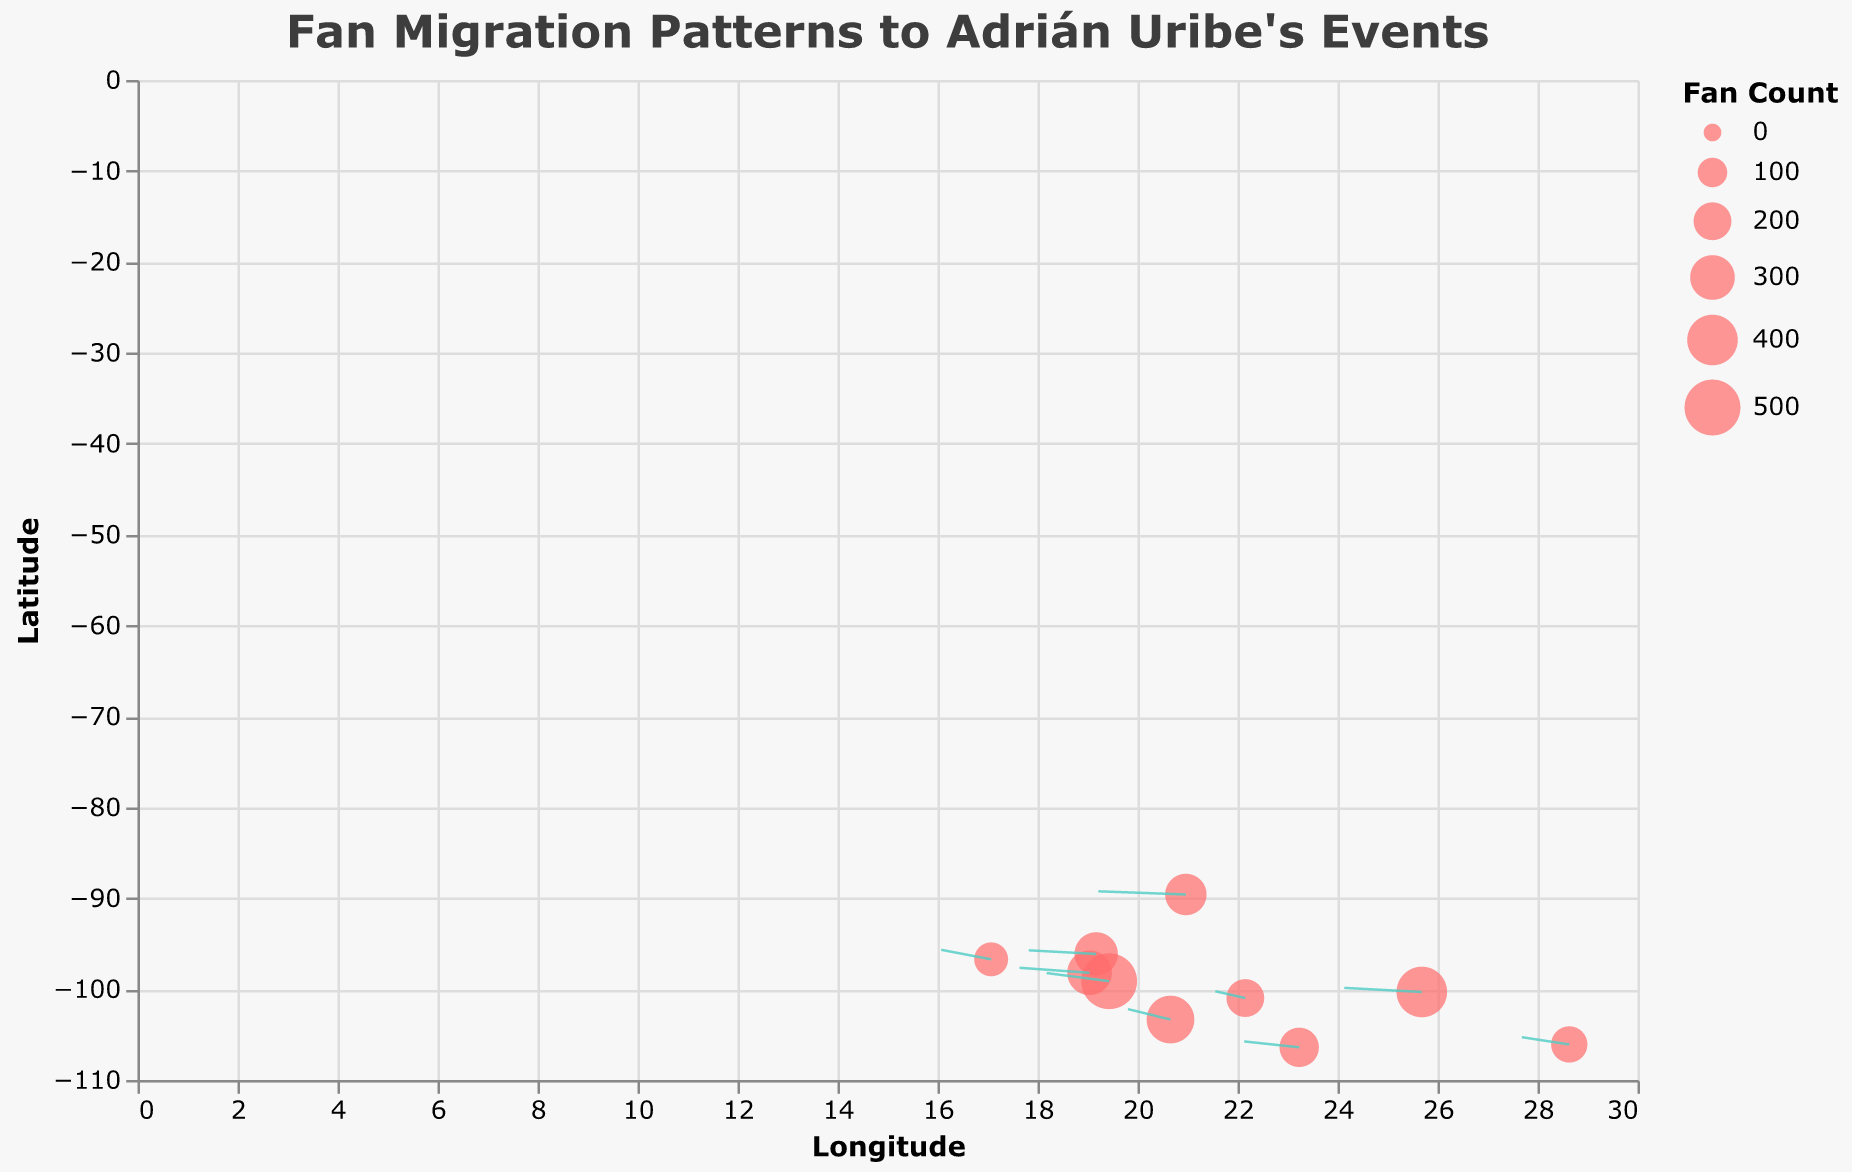What is the title of the plot? The title of the plot can be found at the top of the figure. It reads "Fan Migration Patterns to Adrián Uribe's Events."
Answer: Fan Migration Patterns to Adrián Uribe's Events What variable represents the fan count at each location? The size of the points in the plot represents the fan count at each location. This can be verified by observing the legend labeled "Fan Count."
Answer: size of the points How many data points are plotted in the figure? Each row of the data corresponds to one data point plotted in the figure. By counting the rows, we can see there are 10 data points.
Answer: 10 Which location has the highest fan count? The fan count is represented by the size of the points. The largest point corresponds to the highest fan count, which is at longitude 19.4326 and latitude -99.1332.
Answer: 19.4326, -99.1332 What is the direction of migration from longitude 25.6866 and latitude -100.3161? The direction can be determined by the (u, v) components. For the location at 25.6866, -100.3161, u = -3.1 and v = 0.9. This means the migration direction is roughly southwest.
Answer: southwest What is the magnitude of fan migration from latitude 20.9674 and longitude -89.5926? The magnitude of fan migration is provided directly in the data. For latitude 20.9674 and longitude -89.5926, the magnitude is 250.
Answer: 250 Comparing the states at longitude 19.0414 and 17.0732, which one has a larger magnitude of fan migration? By comparing the "magnitude" values for these locations, we see that 19.0414, -98.2063 has a magnitude of 300 and 17.0732, -96.7266 has a magnitude of 150. Thus, 19.0414, -98.2063 has a larger magnitude.
Answer: 19.0414, -98.2063 What is the average direction of migration for the first three data points? The average direction can be calculated by averaging the u and v components of the first three data points. First three u's: (-2.5, -1.7, -3.1), average u: (-2.5 - 1.7 - 3.1)/3 = -2.43; first three v's: (1.8, 2.3, 0.9), average v: (1.8 + 2.3 + 0.9)/3 = 1.67. Thus, the average direction is (-2.43, 1.67).
Answer: (-2.43, 1.67) For the point at longitude 19.1738 and latitude -96.1342, what are the coordinates of the endpoint of its arrow? The endpoint can be calculated by adding the (u, v) components scaled by 0.5 to the starting point (x, y). Start: (19.1738, -96.1342); u: -2.7, v: 0.8. Endpoint: (19.1738 + (-2.7 * 0.5), -96.1342 + (0.8 * 0.5)) = (17.8238, -95.7342).
Answer: (17.8238, -95.7342) Which data point has the most significant horizontal migration component? The horizontal migration component is represented by the absolute value of the u coordinate. The point with the largest absolute u coordinate is at longitude 20.9674 and latitude -89.5926 with u = -3.5.
Answer: 20.9674, -89.5926 